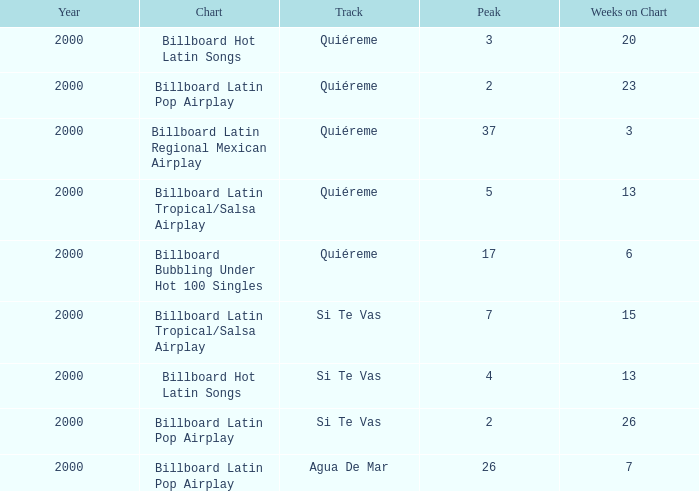What is the fewest number of weeks for a year preceding 2000? None. 